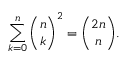Convert formula to latex. <formula><loc_0><loc_0><loc_500><loc_500>\sum _ { k = 0 } ^ { n } { \binom { n } { k } } ^ { 2 } = { \binom { 2 n } { n } } .</formula> 